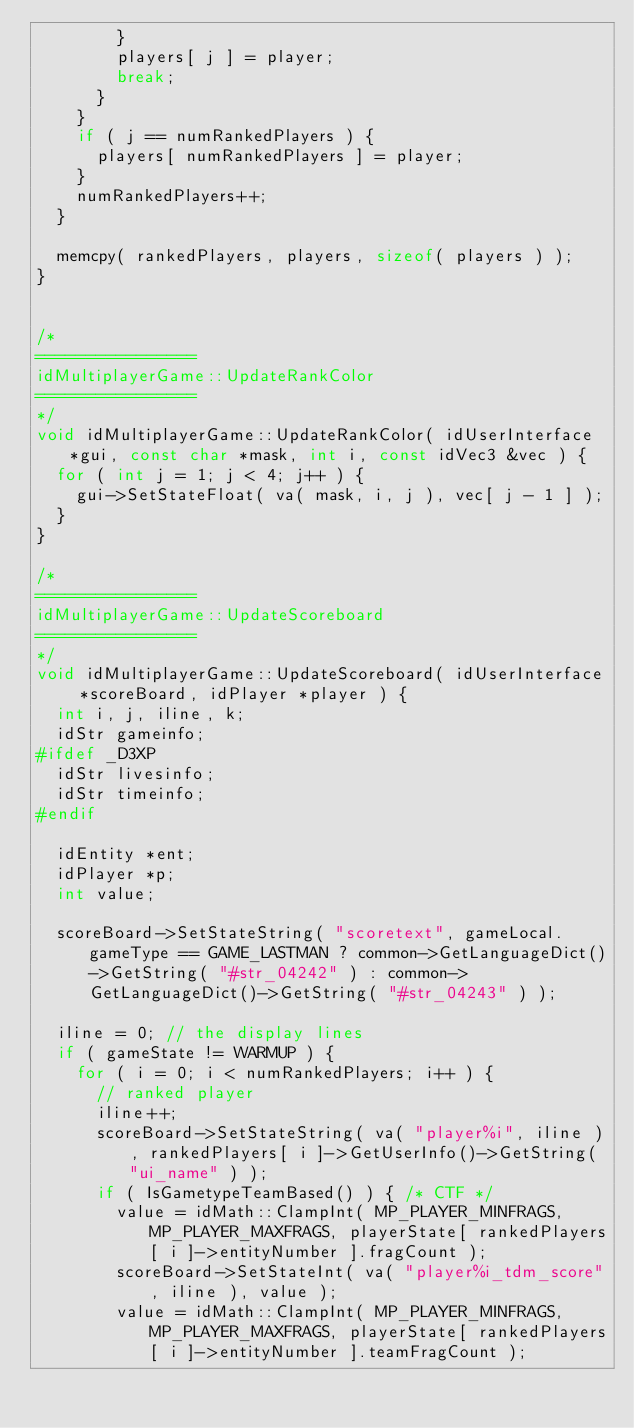Convert code to text. <code><loc_0><loc_0><loc_500><loc_500><_C++_>				}
				players[ j ] = player;
				break;
			}
		}
		if ( j == numRankedPlayers ) {
			players[ numRankedPlayers ] = player;
		}
		numRankedPlayers++;
	}

	memcpy( rankedPlayers, players, sizeof( players ) );
}


/*
================
idMultiplayerGame::UpdateRankColor
================
*/
void idMultiplayerGame::UpdateRankColor( idUserInterface *gui, const char *mask, int i, const idVec3 &vec ) {
	for ( int j = 1; j < 4; j++ ) {
		gui->SetStateFloat( va( mask, i, j ), vec[ j - 1 ] );
	}
}

/*
================
idMultiplayerGame::UpdateScoreboard
================
*/
void idMultiplayerGame::UpdateScoreboard( idUserInterface *scoreBoard, idPlayer *player ) {
	int i, j, iline, k;
	idStr gameinfo;
#ifdef _D3XP
	idStr livesinfo;
	idStr timeinfo;
#endif

	idEntity *ent;
	idPlayer *p;
	int value;

	scoreBoard->SetStateString( "scoretext", gameLocal.gameType == GAME_LASTMAN ? common->GetLanguageDict()->GetString( "#str_04242" ) : common->GetLanguageDict()->GetString( "#str_04243" ) );

	iline = 0; // the display lines
	if ( gameState != WARMUP ) {
		for ( i = 0; i < numRankedPlayers; i++ ) {
			// ranked player
			iline++;
			scoreBoard->SetStateString( va( "player%i", iline ), rankedPlayers[ i ]->GetUserInfo()->GetString( "ui_name" ) );
			if ( IsGametypeTeamBased() ) { /* CTF */
				value = idMath::ClampInt( MP_PLAYER_MINFRAGS, MP_PLAYER_MAXFRAGS, playerState[ rankedPlayers[ i ]->entityNumber ].fragCount );
				scoreBoard->SetStateInt( va( "player%i_tdm_score", iline ), value );
				value = idMath::ClampInt( MP_PLAYER_MINFRAGS, MP_PLAYER_MAXFRAGS, playerState[ rankedPlayers[ i ]->entityNumber ].teamFragCount );</code> 